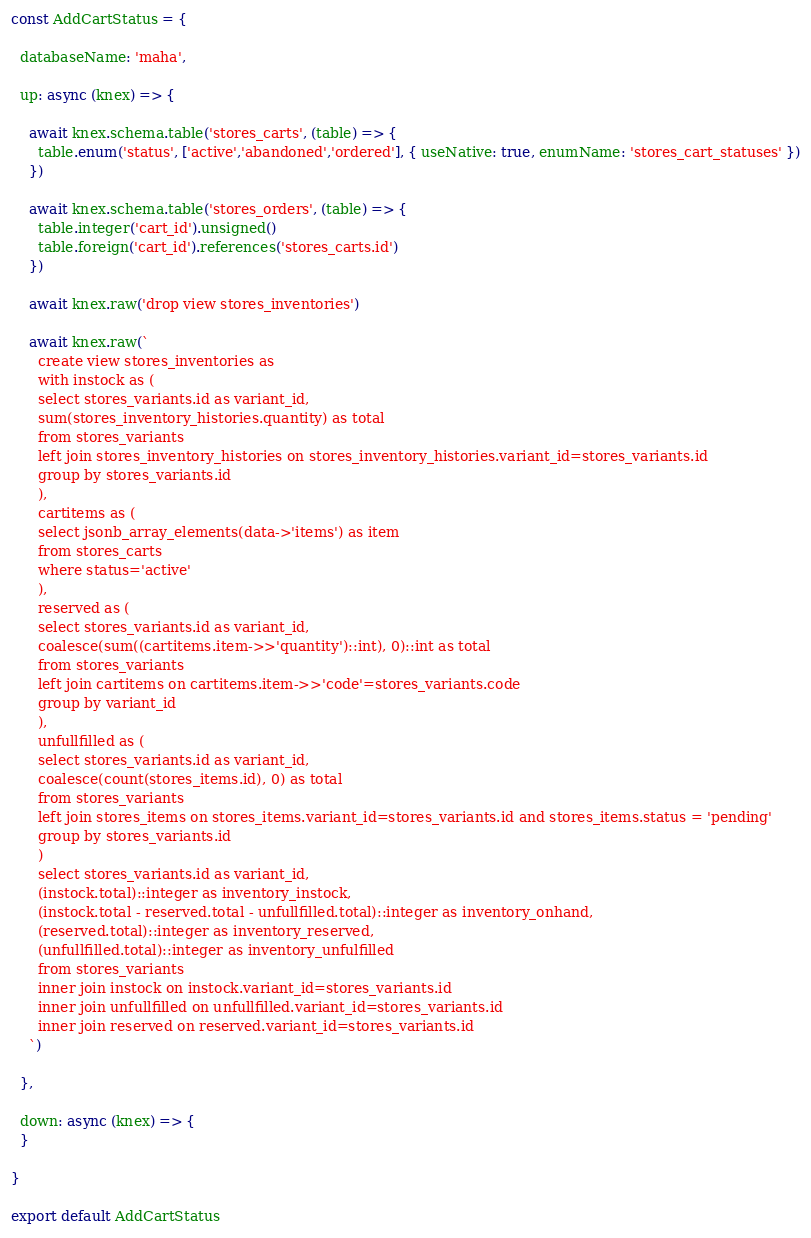Convert code to text. <code><loc_0><loc_0><loc_500><loc_500><_JavaScript_>const AddCartStatus = {

  databaseName: 'maha',

  up: async (knex) => {

    await knex.schema.table('stores_carts', (table) => {
      table.enum('status', ['active','abandoned','ordered'], { useNative: true, enumName: 'stores_cart_statuses' })
    })

    await knex.schema.table('stores_orders', (table) => {
      table.integer('cart_id').unsigned()
      table.foreign('cart_id').references('stores_carts.id')
    })

    await knex.raw('drop view stores_inventories')

    await knex.raw(`
      create view stores_inventories as
      with instock as (
      select stores_variants.id as variant_id,
      sum(stores_inventory_histories.quantity) as total
      from stores_variants
      left join stores_inventory_histories on stores_inventory_histories.variant_id=stores_variants.id
      group by stores_variants.id
      ),
      cartitems as (
      select jsonb_array_elements(data->'items') as item
      from stores_carts
      where status='active'
      ),
      reserved as (
      select stores_variants.id as variant_id,
      coalesce(sum((cartitems.item->>'quantity')::int), 0)::int as total
      from stores_variants
      left join cartitems on cartitems.item->>'code'=stores_variants.code
      group by variant_id
      ),
      unfullfilled as (
      select stores_variants.id as variant_id,
      coalesce(count(stores_items.id), 0) as total
      from stores_variants
      left join stores_items on stores_items.variant_id=stores_variants.id and stores_items.status = 'pending'
      group by stores_variants.id
      )
      select stores_variants.id as variant_id,
      (instock.total)::integer as inventory_instock,
      (instock.total - reserved.total - unfullfilled.total)::integer as inventory_onhand,
      (reserved.total)::integer as inventory_reserved,
      (unfullfilled.total)::integer as inventory_unfulfilled
      from stores_variants
      inner join instock on instock.variant_id=stores_variants.id
      inner join unfullfilled on unfullfilled.variant_id=stores_variants.id
      inner join reserved on reserved.variant_id=stores_variants.id
    `)

  },

  down: async (knex) => {
  }

}

export default AddCartStatus
</code> 